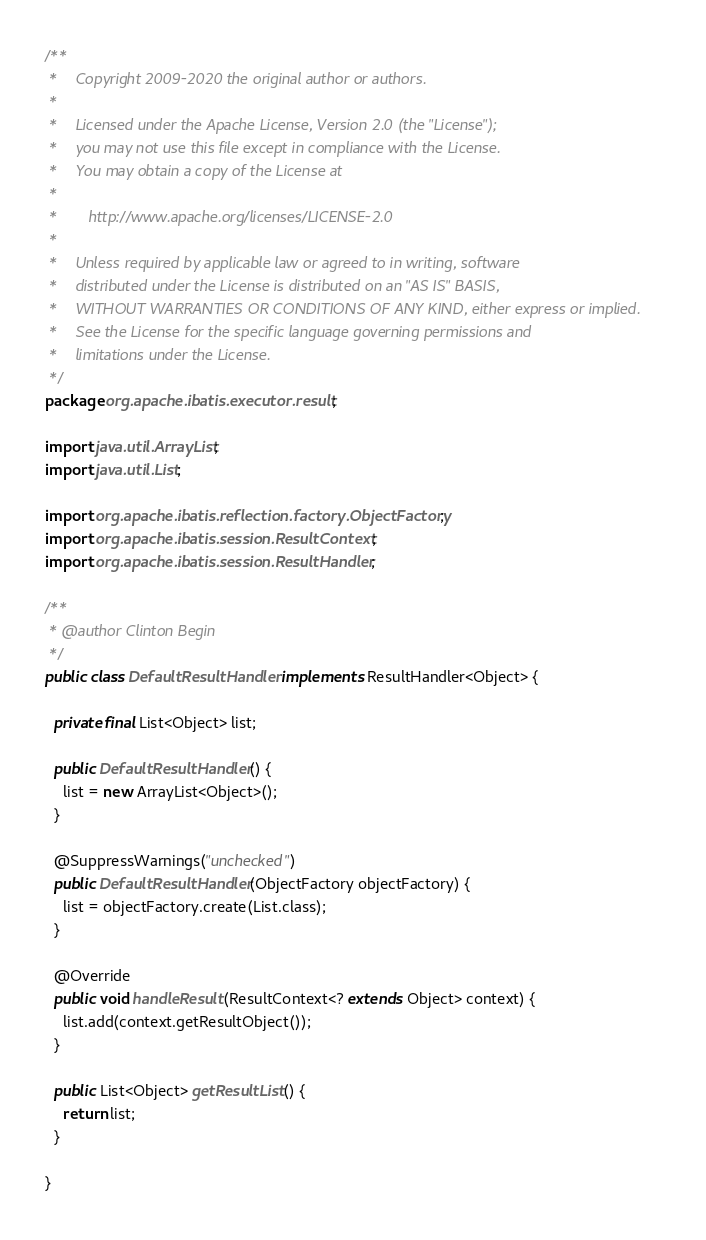Convert code to text. <code><loc_0><loc_0><loc_500><loc_500><_Java_>/**
 *    Copyright 2009-2020 the original author or authors.
 *
 *    Licensed under the Apache License, Version 2.0 (the "License");
 *    you may not use this file except in compliance with the License.
 *    You may obtain a copy of the License at
 *
 *       http://www.apache.org/licenses/LICENSE-2.0
 *
 *    Unless required by applicable law or agreed to in writing, software
 *    distributed under the License is distributed on an "AS IS" BASIS,
 *    WITHOUT WARRANTIES OR CONDITIONS OF ANY KIND, either express or implied.
 *    See the License for the specific language governing permissions and
 *    limitations under the License.
 */
package org.apache.ibatis.executor.result;

import java.util.ArrayList;
import java.util.List;

import org.apache.ibatis.reflection.factory.ObjectFactory;
import org.apache.ibatis.session.ResultContext;
import org.apache.ibatis.session.ResultHandler;

/**
 * @author Clinton Begin
 */
public class DefaultResultHandler implements ResultHandler<Object> {

  private final List<Object> list;

  public DefaultResultHandler() {
    list = new ArrayList<Object>();
  }

  @SuppressWarnings("unchecked")
  public DefaultResultHandler(ObjectFactory objectFactory) {
    list = objectFactory.create(List.class);
  }

  @Override
  public void handleResult(ResultContext<? extends Object> context) {
    list.add(context.getResultObject());
  }

  public List<Object> getResultList() {
    return list;
  }

}
</code> 